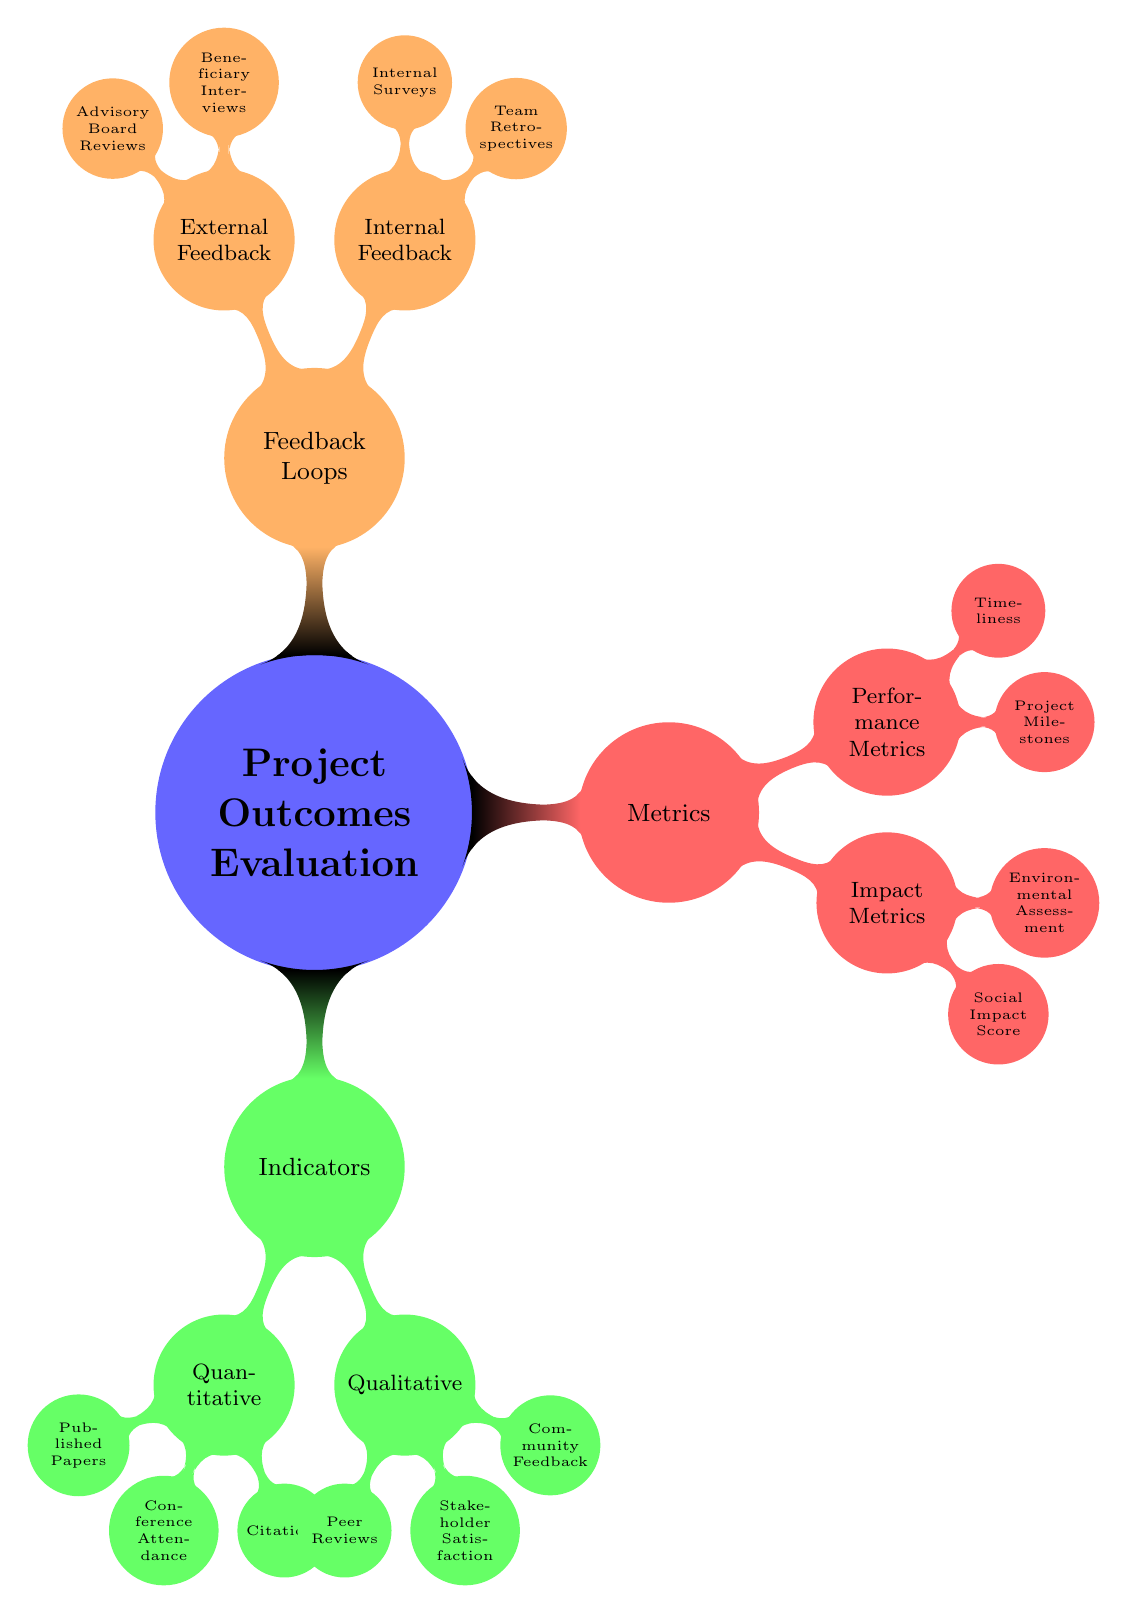What are the two categories of indicators listed in the diagram? The diagram shows two categories under the section Indicators: Quantitative and Qualitative.
Answer: Quantitative and Qualitative How many quantitative indicators are listed? The quantitative indicators include 'Number of Published Papers', 'Attendance at Conferences', and 'Number of Citations'. This gives us a total of three indicators.
Answer: 3 Which type of feedback is collected internally? Internal feedback methods include 'Team Retrospectives' and 'Internal Surveys' as noted in the Feedback Loops section of the diagram.
Answer: Team Retrospectives and Internal Surveys What are the two types of metrics identified in the diagram? The metrics category in the diagram has two types: Impact Metrics and Performance Metrics.
Answer: Impact Metrics and Performance Metrics How many items are there under external feedback? The diagram shows two external feedback methods: 'Interviews with Beneficiaries' and 'Advisory Board Reviews', which means there are two items listed.
Answer: 2 Which indicator is found under the qualitative category? The qualitative category lists 'Peer Reviews', 'Stakeholder Satisfaction', and 'Community Feedback'. These indicators show feedback and satisfaction levels.
Answer: Peer Reviews How is the social impact score classified in the diagram? Within the diagram, the 'Social Impact Score' is specifically classified under Impact Metrics within the Metrics section.
Answer: Impact Metrics Name one performance metric mentioned in the diagram. The diagram reflects the performance metrics including 'Project Milestones Achieved' as one of the examples.
Answer: Project Milestones Achieved 